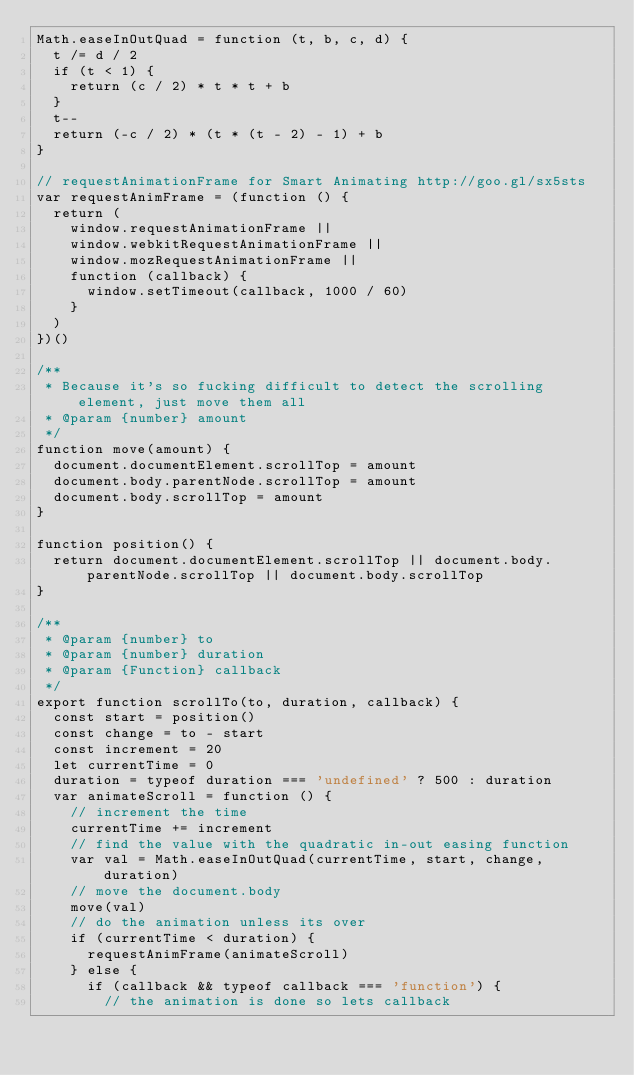<code> <loc_0><loc_0><loc_500><loc_500><_JavaScript_>Math.easeInOutQuad = function (t, b, c, d) {
  t /= d / 2
  if (t < 1) {
    return (c / 2) * t * t + b
  }
  t--
  return (-c / 2) * (t * (t - 2) - 1) + b
}

// requestAnimationFrame for Smart Animating http://goo.gl/sx5sts
var requestAnimFrame = (function () {
  return (
    window.requestAnimationFrame ||
    window.webkitRequestAnimationFrame ||
    window.mozRequestAnimationFrame ||
    function (callback) {
      window.setTimeout(callback, 1000 / 60)
    }
  )
})()

/**
 * Because it's so fucking difficult to detect the scrolling element, just move them all
 * @param {number} amount
 */
function move(amount) {
  document.documentElement.scrollTop = amount
  document.body.parentNode.scrollTop = amount
  document.body.scrollTop = amount
}

function position() {
  return document.documentElement.scrollTop || document.body.parentNode.scrollTop || document.body.scrollTop
}

/**
 * @param {number} to
 * @param {number} duration
 * @param {Function} callback
 */
export function scrollTo(to, duration, callback) {
  const start = position()
  const change = to - start
  const increment = 20
  let currentTime = 0
  duration = typeof duration === 'undefined' ? 500 : duration
  var animateScroll = function () {
    // increment the time
    currentTime += increment
    // find the value with the quadratic in-out easing function
    var val = Math.easeInOutQuad(currentTime, start, change, duration)
    // move the document.body
    move(val)
    // do the animation unless its over
    if (currentTime < duration) {
      requestAnimFrame(animateScroll)
    } else {
      if (callback && typeof callback === 'function') {
        // the animation is done so lets callback</code> 